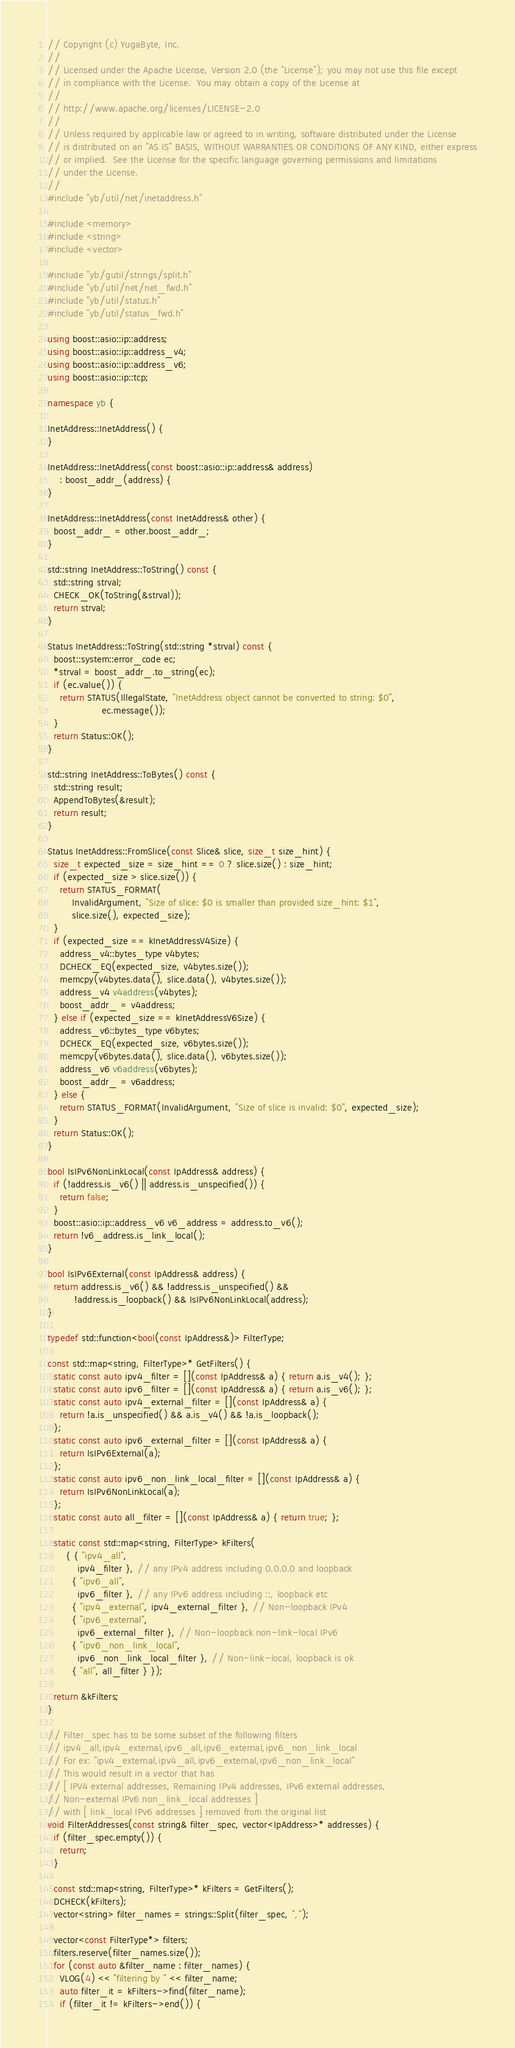Convert code to text. <code><loc_0><loc_0><loc_500><loc_500><_C++_>// Copyright (c) YugaByte, Inc.
//
// Licensed under the Apache License, Version 2.0 (the "License"); you may not use this file except
// in compliance with the License.  You may obtain a copy of the License at
//
// http://www.apache.org/licenses/LICENSE-2.0
//
// Unless required by applicable law or agreed to in writing, software distributed under the License
// is distributed on an "AS IS" BASIS, WITHOUT WARRANTIES OR CONDITIONS OF ANY KIND, either express
// or implied.  See the License for the specific language governing permissions and limitations
// under the License.
//
#include "yb/util/net/inetaddress.h"

#include <memory>
#include <string>
#include <vector>

#include "yb/gutil/strings/split.h"
#include "yb/util/net/net_fwd.h"
#include "yb/util/status.h"
#include "yb/util/status_fwd.h"

using boost::asio::ip::address;
using boost::asio::ip::address_v4;
using boost::asio::ip::address_v6;
using boost::asio::ip::tcp;

namespace yb {

InetAddress::InetAddress() {
}

InetAddress::InetAddress(const boost::asio::ip::address& address)
    : boost_addr_(address) {
}

InetAddress::InetAddress(const InetAddress& other) {
  boost_addr_ = other.boost_addr_;
}

std::string InetAddress::ToString() const {
  std::string strval;
  CHECK_OK(ToString(&strval));
  return strval;
}

Status InetAddress::ToString(std::string *strval) const {
  boost::system::error_code ec;
  *strval = boost_addr_.to_string(ec);
  if (ec.value()) {
    return STATUS(IllegalState, "InetAddress object cannot be converted to string: $0",
                  ec.message());
  }
  return Status::OK();
}

std::string InetAddress::ToBytes() const {
  std::string result;
  AppendToBytes(&result);
  return result;
}

Status InetAddress::FromSlice(const Slice& slice, size_t size_hint) {
  size_t expected_size = size_hint == 0 ? slice.size() : size_hint;
  if (expected_size > slice.size()) {
    return STATUS_FORMAT(
        InvalidArgument, "Size of slice: $0 is smaller than provided size_hint: $1",
        slice.size(), expected_size);
  }
  if (expected_size == kInetAddressV4Size) {
    address_v4::bytes_type v4bytes;
    DCHECK_EQ(expected_size, v4bytes.size());
    memcpy(v4bytes.data(), slice.data(), v4bytes.size());
    address_v4 v4address(v4bytes);
    boost_addr_ = v4address;
  } else if (expected_size == kInetAddressV6Size) {
    address_v6::bytes_type v6bytes;
    DCHECK_EQ(expected_size, v6bytes.size());
    memcpy(v6bytes.data(), slice.data(), v6bytes.size());
    address_v6 v6address(v6bytes);
    boost_addr_ = v6address;
  } else {
    return STATUS_FORMAT(InvalidArgument, "Size of slice is invalid: $0", expected_size);
  }
  return Status::OK();
}

bool IsIPv6NonLinkLocal(const IpAddress& address) {
  if (!address.is_v6() || address.is_unspecified()) {
    return false;
  }
  boost::asio::ip::address_v6 v6_address = address.to_v6();
  return !v6_address.is_link_local();
}

bool IsIPv6External(const IpAddress& address) {
  return address.is_v6() && !address.is_unspecified() &&
         !address.is_loopback() && IsIPv6NonLinkLocal(address);
}

typedef std::function<bool(const IpAddress&)> FilterType;

const std::map<string, FilterType>* GetFilters() {
  static const auto ipv4_filter = [](const IpAddress& a) { return a.is_v4(); };
  static const auto ipv6_filter = [](const IpAddress& a) { return a.is_v6(); };
  static const auto ipv4_external_filter = [](const IpAddress& a) {
    return !a.is_unspecified() && a.is_v4() && !a.is_loopback();
  };
  static const auto ipv6_external_filter = [](const IpAddress& a) {
    return IsIPv6External(a);
  };
  static const auto ipv6_non_link_local_filter = [](const IpAddress& a) {
    return IsIPv6NonLinkLocal(a);
  };
  static const auto all_filter = [](const IpAddress& a) { return true; };

  static const std::map<string, FilterType> kFilters(
      { { "ipv4_all",
          ipv4_filter }, // any IPv4 address including 0.0.0.0 and loopback
        { "ipv6_all",
          ipv6_filter }, // any IPv6 address including ::, loopback etc
        { "ipv4_external", ipv4_external_filter }, // Non-loopback IPv4
        { "ipv6_external",
          ipv6_external_filter }, // Non-loopback non-link-local IPv6
        { "ipv6_non_link_local",
          ipv6_non_link_local_filter }, // Non-link-local, loopback is ok
        { "all", all_filter } });

  return &kFilters;
}

// Filter_spec has to be some subset of the following filters
// ipv4_all,ipv4_external,ipv6_all,ipv6_external,ipv6_non_link_local
// For ex: "ipv4_external,ipv4_all,ipv6_external,ipv6_non_link_local"
// This would result in a vector that has
// [ IPV4 external addresses, Remaining IPv4 addresses, IPv6 external addresses,
// Non-external IPv6 non_link_local addresses ]
// with [ link_local IPv6 addresses ] removed from the original list
void FilterAddresses(const string& filter_spec, vector<IpAddress>* addresses) {
  if (filter_spec.empty()) {
    return;
  }

  const std::map<string, FilterType>* kFilters = GetFilters();
  DCHECK(kFilters);
  vector<string> filter_names = strings::Split(filter_spec, ",");

  vector<const FilterType*> filters;
  filters.reserve(filter_names.size());
  for (const auto &filter_name : filter_names) {
    VLOG(4) << "filtering by " << filter_name;
    auto filter_it = kFilters->find(filter_name);
    if (filter_it != kFilters->end()) {</code> 